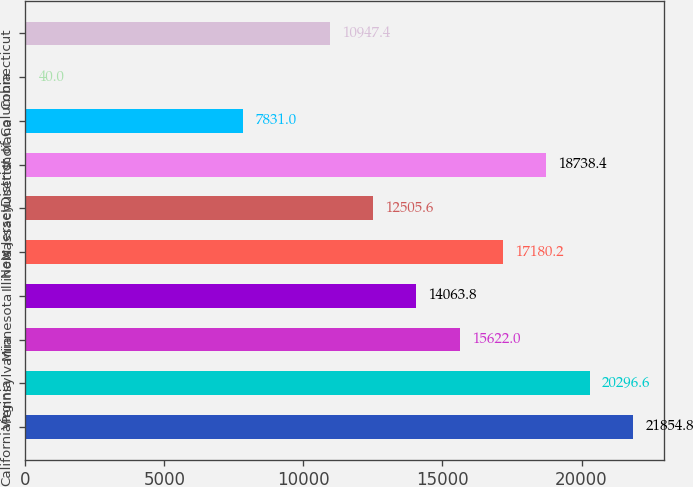<chart> <loc_0><loc_0><loc_500><loc_500><bar_chart><fcel>California<fcel>Virginia<fcel>Pennsylvania<fcel>Minnesota<fcel>Illinois<fcel>New Jersey<fcel>Massachusetts<fcel>Indiana<fcel>District of Columbia<fcel>Connecticut<nl><fcel>21854.8<fcel>20296.6<fcel>15622<fcel>14063.8<fcel>17180.2<fcel>12505.6<fcel>18738.4<fcel>7831<fcel>40<fcel>10947.4<nl></chart> 